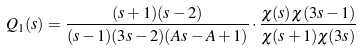<formula> <loc_0><loc_0><loc_500><loc_500>Q _ { 1 } ( s ) = \frac { ( s + 1 ) ( s - 2 ) } { ( s - 1 ) ( 3 s - 2 ) ( A s - A + 1 ) } \cdot \frac { \chi ( s ) \chi ( 3 s - 1 ) } { \chi ( s + 1 ) \chi ( 3 s ) }</formula> 